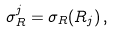<formula> <loc_0><loc_0><loc_500><loc_500>\sigma _ { R } ^ { j } = \sigma _ { R } ( R _ { j } ) \, ,</formula> 